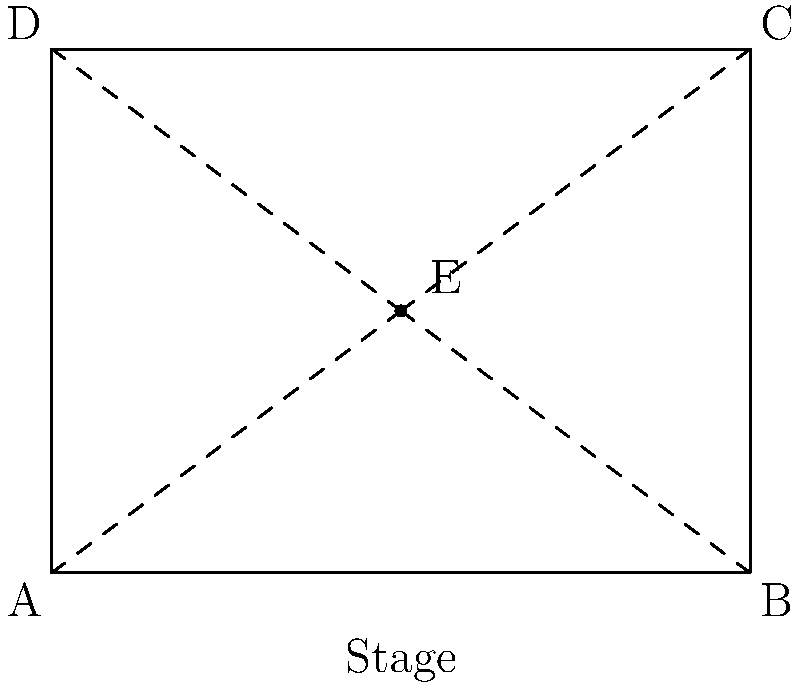In preparation for a special concert event, the stadium seating chart needs to be rotated 90° clockwise around point E to accommodate a new stage layout. After the rotation, what will be the coordinates of point C? To solve this problem, we'll follow these steps:

1) First, identify the center of rotation (E) and its coordinates:
   E = (2, 1.5)

2) Identify the original coordinates of point C:
   C = (4, 3)

3) To rotate 90° clockwise around E, we can use the rotation formula:
   $x' = x_E + (x - x_E)\cos\theta - (y - y_E)\sin\theta$
   $y' = y_E + (x - x_E)\sin\theta + (y - y_E)\cos\theta$

   Where $(x, y)$ are the original coordinates, $(x', y')$ are the new coordinates, $(x_E, y_E)$ are the coordinates of E, and $\theta$ is the angle of rotation.

4) For a 90° clockwise rotation, $\cos\theta = 0$ and $\sin\theta = -1$

5) Plug in the values:
   $x' = 2 + (4 - 2)(0) - (3 - 1.5)(-1) = 2 + 1.5 = 3.5$
   $y' = 1.5 + (4 - 2)(-1) + (3 - 1.5)(0) = 1.5 - 2 = -0.5$

6) Therefore, after rotation, the new coordinates of C are (3.5, -0.5)
Answer: (3.5, -0.5) 